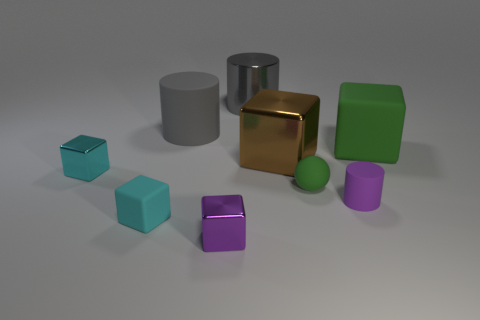Is the small matte ball the same color as the large rubber block?
Make the answer very short. Yes. There is a cube that is the same color as the small cylinder; what material is it?
Ensure brevity in your answer.  Metal. Does the shiny object that is on the left side of the small purple metal block have the same color as the tiny rubber block?
Provide a short and direct response. Yes. What number of other objects are the same color as the small ball?
Your response must be concise. 1. There is a matte object on the right side of the small purple rubber object; is its shape the same as the gray matte object?
Keep it short and to the point. No. What is the material of the ball that is the same size as the purple rubber thing?
Offer a terse response. Rubber. There is a ball; is it the same color as the large cube right of the small purple matte thing?
Provide a succinct answer. Yes. Are there fewer purple things to the right of the matte ball than small spheres?
Your answer should be compact. No. How many yellow matte cubes are there?
Your answer should be compact. 0. The gray object that is behind the large cylinder in front of the gray metallic thing is what shape?
Give a very brief answer. Cylinder. 